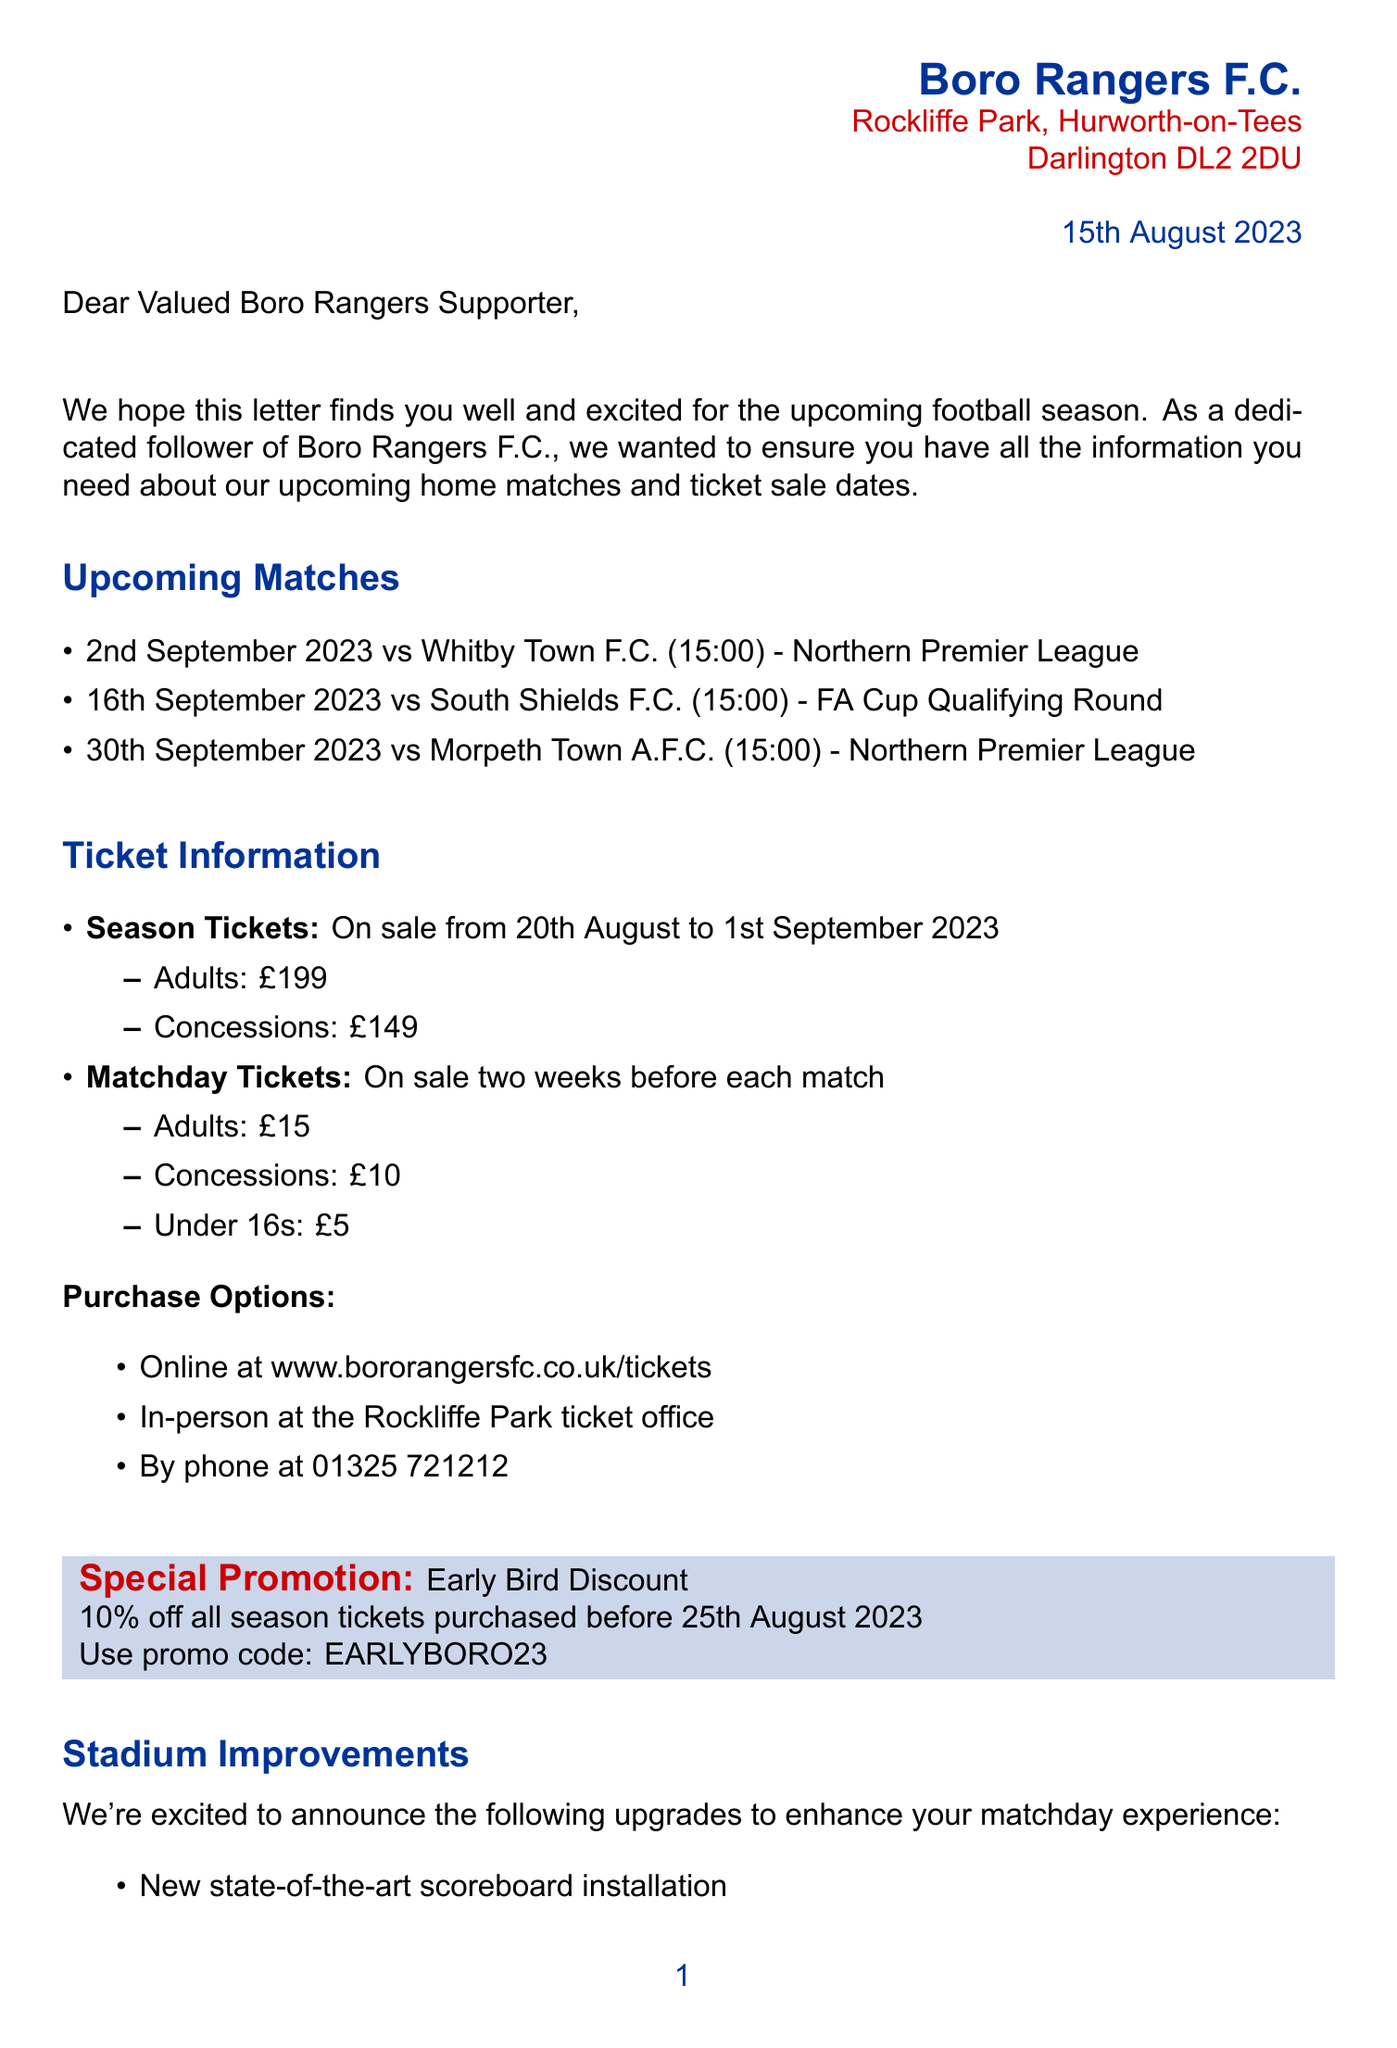what is the date of the first home match? The first home match is against Whitby Town F.C. on 2nd September 2023.
Answer: 2nd September 2023 what is the price of an adult matchday ticket? The document states that adult matchday tickets are priced at £15.
Answer: £15 who is the chairman of Boro Rangers F.C.? The document names Steve Gibson as the chairman of Boro Rangers F.C.
Answer: Steve Gibson when do season ticket sales start? The sales for season tickets begin on 20th August 2023 according to the document.
Answer: 20th August 2023 what promotion is offered for season tickets? The document mentions an Early Bird Discount for season tickets.
Answer: Early Bird Discount how much discount is available if season tickets are purchased early? The letter states a 10% discount for early purchases of season tickets.
Answer: 10% what is the kickoff time for the match against South Shields F.C.? According to the document, the kickoff time for the match against South Shields F.C. is at 15:00.
Answer: 15:00 how can tickets be purchased? The document lists multiple purchase options including online, in-person, or by phone.
Answer: Online, in-person, by phone how long does the community initiative offer free entry for youth players? The initiative allows free entry for youth players who come with a paying adult to any home match.
Answer: Any home match 